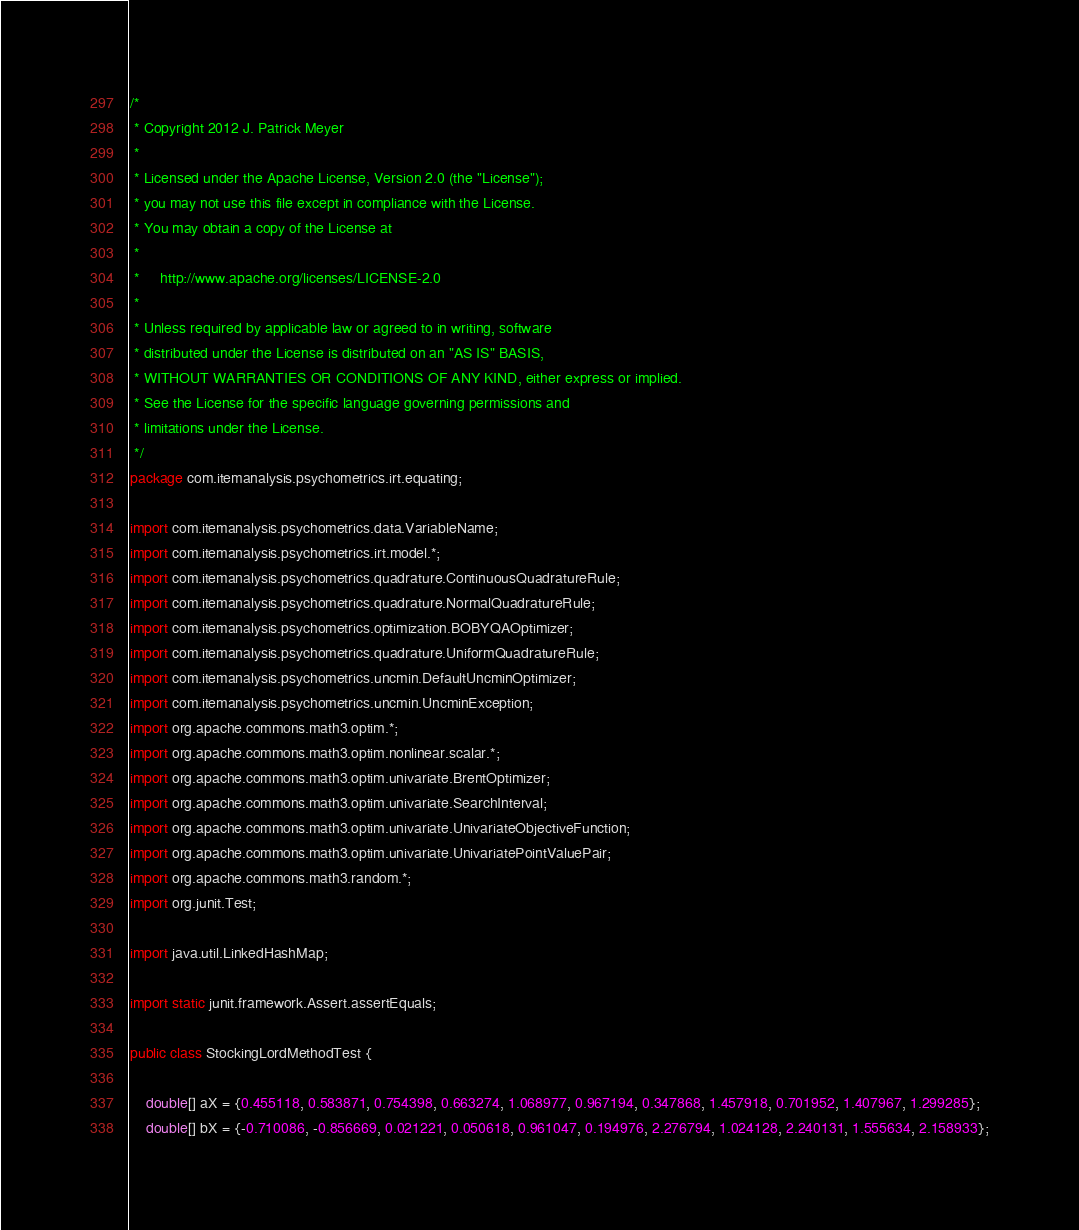Convert code to text. <code><loc_0><loc_0><loc_500><loc_500><_Java_>/*
 * Copyright 2012 J. Patrick Meyer
 *
 * Licensed under the Apache License, Version 2.0 (the "License");
 * you may not use this file except in compliance with the License.
 * You may obtain a copy of the License at
 *
 *     http://www.apache.org/licenses/LICENSE-2.0
 *
 * Unless required by applicable law or agreed to in writing, software
 * distributed under the License is distributed on an "AS IS" BASIS,
 * WITHOUT WARRANTIES OR CONDITIONS OF ANY KIND, either express or implied.
 * See the License for the specific language governing permissions and
 * limitations under the License.
 */
package com.itemanalysis.psychometrics.irt.equating;

import com.itemanalysis.psychometrics.data.VariableName;
import com.itemanalysis.psychometrics.irt.model.*;
import com.itemanalysis.psychometrics.quadrature.ContinuousQuadratureRule;
import com.itemanalysis.psychometrics.quadrature.NormalQuadratureRule;
import com.itemanalysis.psychometrics.optimization.BOBYQAOptimizer;
import com.itemanalysis.psychometrics.quadrature.UniformQuadratureRule;
import com.itemanalysis.psychometrics.uncmin.DefaultUncminOptimizer;
import com.itemanalysis.psychometrics.uncmin.UncminException;
import org.apache.commons.math3.optim.*;
import org.apache.commons.math3.optim.nonlinear.scalar.*;
import org.apache.commons.math3.optim.univariate.BrentOptimizer;
import org.apache.commons.math3.optim.univariate.SearchInterval;
import org.apache.commons.math3.optim.univariate.UnivariateObjectiveFunction;
import org.apache.commons.math3.optim.univariate.UnivariatePointValuePair;
import org.apache.commons.math3.random.*;
import org.junit.Test;

import java.util.LinkedHashMap;

import static junit.framework.Assert.assertEquals;

public class StockingLordMethodTest {

    double[] aX = {0.455118, 0.583871, 0.754398, 0.663274, 1.068977, 0.967194, 0.347868, 1.457918, 0.701952, 1.407967, 1.299285};
    double[] bX = {-0.710086, -0.856669, 0.021221, 0.050618, 0.961047, 0.194976, 2.276794, 1.024128, 2.240131, 1.555634, 2.158933};</code> 